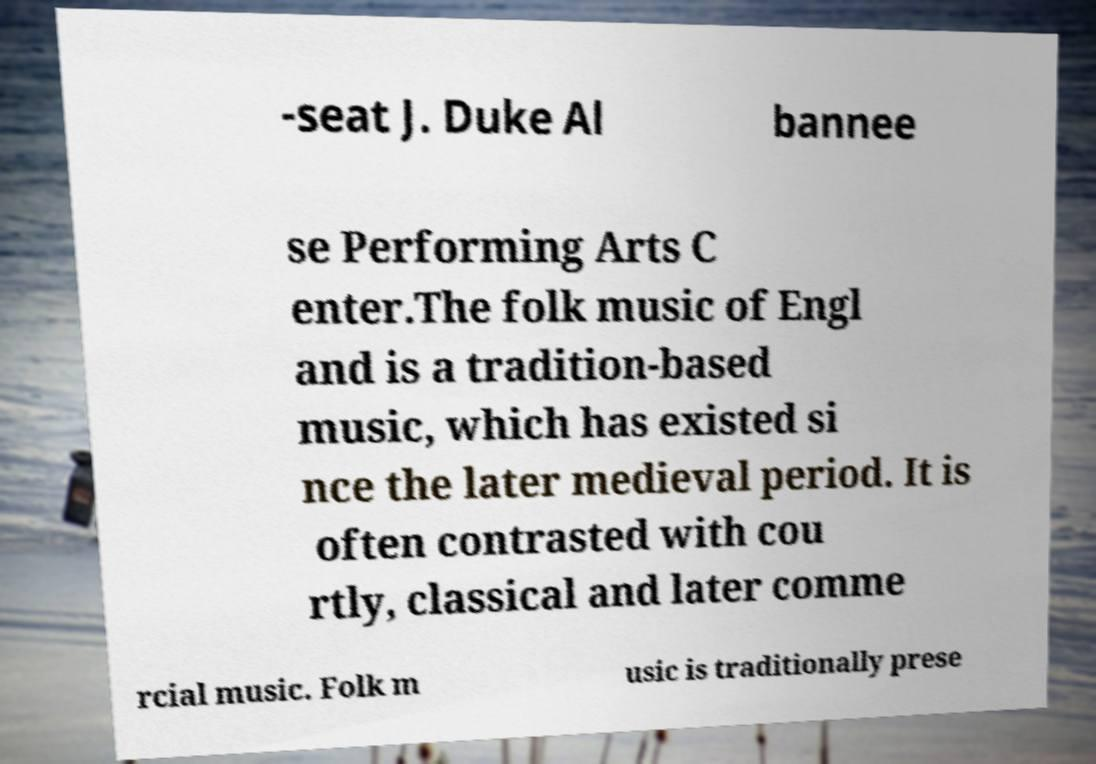Can you accurately transcribe the text from the provided image for me? -seat J. Duke Al bannee se Performing Arts C enter.The folk music of Engl and is a tradition-based music, which has existed si nce the later medieval period. It is often contrasted with cou rtly, classical and later comme rcial music. Folk m usic is traditionally prese 